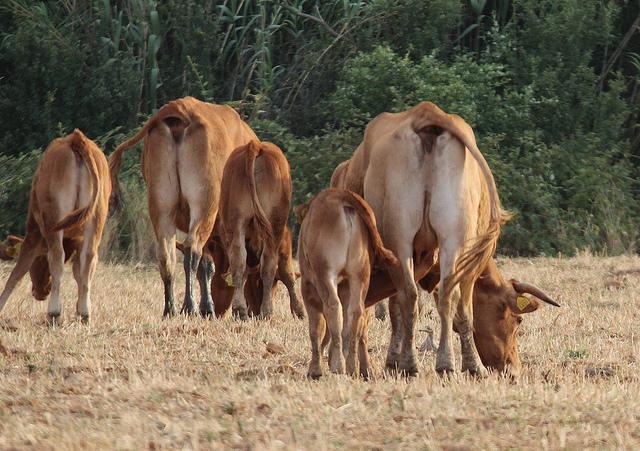How many cows are there?
Give a very brief answer. 5. 